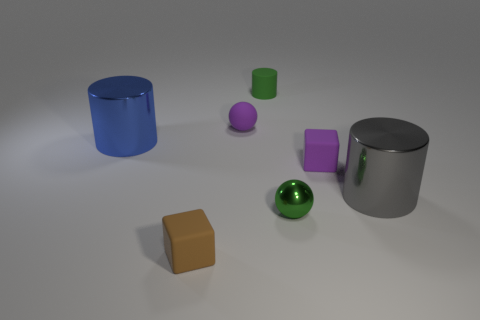What is the shape of the matte object that is the same color as the matte ball?
Give a very brief answer. Cube. Does the cylinder behind the blue thing have the same color as the small shiny object?
Ensure brevity in your answer.  Yes. There is a metallic thing that is on the left side of the brown block; is its size the same as the green cylinder?
Make the answer very short. No. What number of tiny matte things are both behind the brown rubber cube and to the left of the small green sphere?
Give a very brief answer. 2. What is the color of the matte ball?
Offer a terse response. Purple. Is there a blue cylinder that has the same material as the gray thing?
Your answer should be compact. Yes. Are there any green rubber cylinders that are to the right of the tiny purple rubber object in front of the purple matte thing behind the purple cube?
Your answer should be compact. No. Are there any small brown cubes right of the small green matte cylinder?
Keep it short and to the point. No. Is there a small matte cube of the same color as the tiny matte cylinder?
Your answer should be very brief. No. How many tiny things are either green shiny balls or cyan metallic objects?
Your answer should be very brief. 1. 